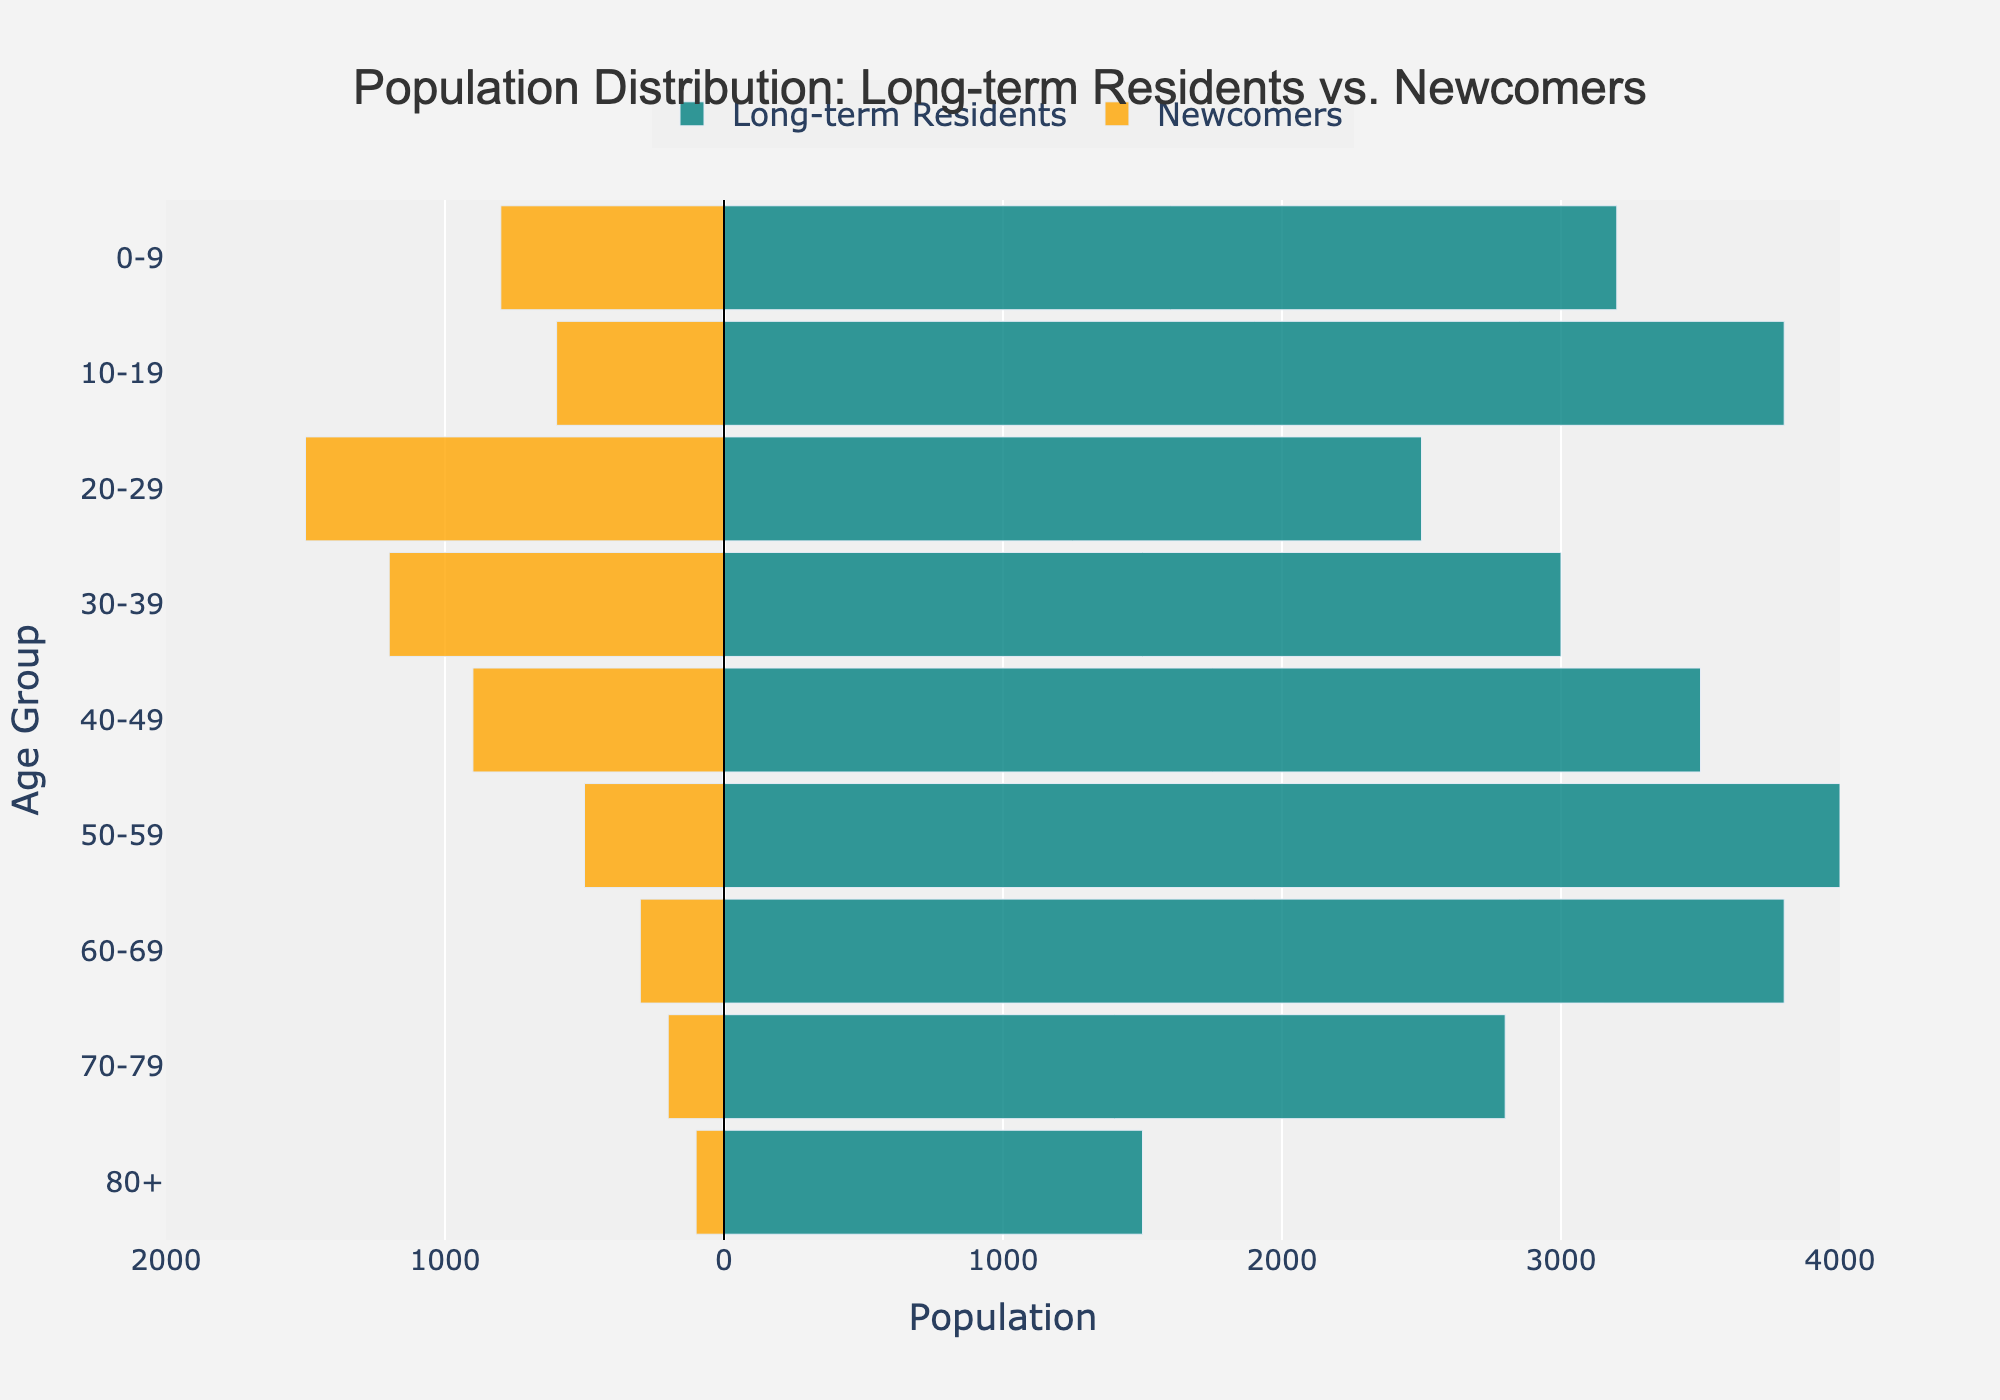What is the title of the figure? The title of the figure is displayed on top and centered. It reads "Population Distribution: Long-term Residents vs. Newcomers".
Answer: Population Distribution: Long-term Residents vs. Newcomers How many age groups are displayed in the figure? By counting the distinct entries on the y-axis, it is discernible that the figure includes data for nine distinct age groups ranging from "0-9" to "80+".
Answer: 9 Which age group has the highest number of long-term residents? On the left side of the figure, the horizontal bars denote long-term residents. The age group "50-59" has the furthest extending bar, notably reaching 4000, indicating the highest number of long-term residents.
Answer: 50-59 How many newcomers are in the age group 20-29? The length of the bar on the right side (in the negative direction) at "20-29" represents the newcomers. This bar extends to 1500.
Answer: 1500 Compare the number of long-term residents versus newcomers in the "30-39" age group. For the "30-39" age group, the figure shows a bar for long-term residents extending to 3000 and a negative bar for newcomers extending to 1200. Therefore, long-term residents are more numerous than newcomers in this age group.
Answer: Long-term residents: 3000, Newcomers: 1200 What is the range of x-axis values? The x-axis values range from -2000 to 4000 as marked with ticks and the tick labels indicate 2000 increments in population both for positive (long-term residents) and negative (newcomers) numbers.
Answer: -2000 to 4000 Which age group has the smallest difference between long-term residents and newcomers? Calculate the difference between the long-term residents and newcomers for each age group. The age group "20-29" has a difference of 1000 (2500 - 1500), which is the smallest among all age groups.
Answer: 20-29 What is the combined total population for the "0-9" age group? Add the number of long-term residents and newcomers for the "0-9" age group. The total is 3200 + 800 = 4000.
Answer: 4000 How does the population distribution of newcomers change with age? Looking at the length of the bars on the negative side of the x-axis, the population of newcomers decreases as age increases, with the highest in "20-29" and lowest in "80+".
Answer: Decreases with age Which age groups have more than 3500 long-term residents? Observing the left side of the pyramid, the age groups "10-19", "40-49", and "50-59" all have bars extending past 3500, indicating they have more than 3500 long-term residents.
Answer: 10-19, 40-49, 50-59 